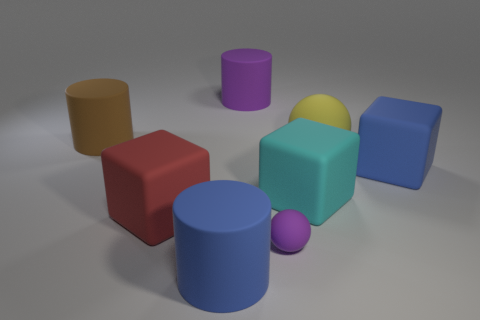Is the size of the cylinder behind the big brown cylinder the same as the rubber sphere that is to the left of the yellow object?
Offer a very short reply. No. What number of red matte objects are behind the matte cylinder left of the big blue rubber object on the left side of the purple matte cylinder?
Make the answer very short. 0. How many things are behind the blue rubber cylinder and in front of the big purple matte cylinder?
Provide a short and direct response. 6. What is the shape of the big object that is behind the brown cylinder?
Keep it short and to the point. Cylinder. Are there fewer purple matte balls that are right of the large yellow rubber ball than big matte cubes that are in front of the cyan object?
Make the answer very short. Yes. What shape is the cyan thing?
Make the answer very short. Cube. Is the number of matte cubes that are to the right of the big red rubber block greater than the number of blue rubber things behind the big purple rubber object?
Provide a short and direct response. Yes. Does the large blue matte thing on the right side of the large cyan rubber thing have the same shape as the purple thing that is in front of the big red object?
Your response must be concise. No. How many other objects are the same size as the brown object?
Ensure brevity in your answer.  6. The purple matte sphere has what size?
Keep it short and to the point. Small. 